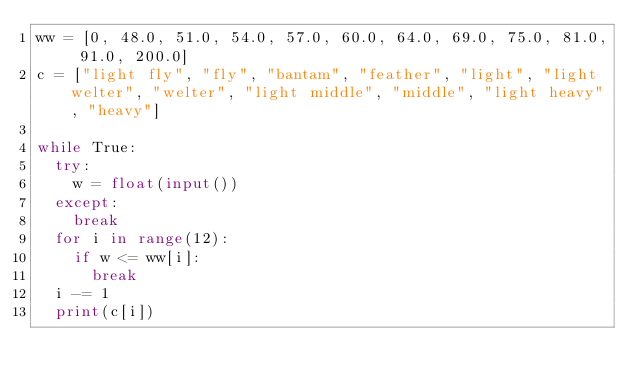Convert code to text. <code><loc_0><loc_0><loc_500><loc_500><_Python_>ww = [0, 48.0, 51.0, 54.0, 57.0, 60.0, 64.0, 69.0, 75.0, 81.0, 91.0, 200.0]
c = ["light fly", "fly", "bantam", "feather", "light", "light welter", "welter", "light middle", "middle", "light heavy", "heavy"]

while True:
  try:
    w = float(input())
  except:
    break
  for i in range(12):
    if w <= ww[i]:
      break
  i -= 1
  print(c[i])
</code> 